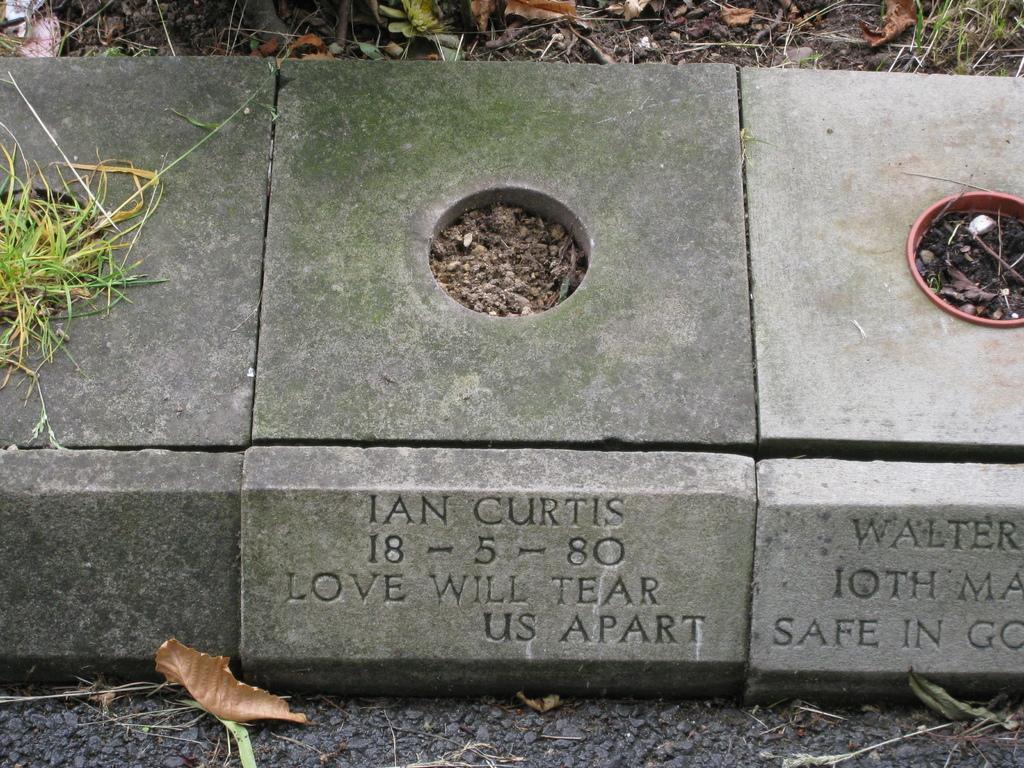Could you give a brief overview of what you see in this image? In this image I can see some memorial stones with a hole in the center on the ground. I can see another stone attached with some text. 